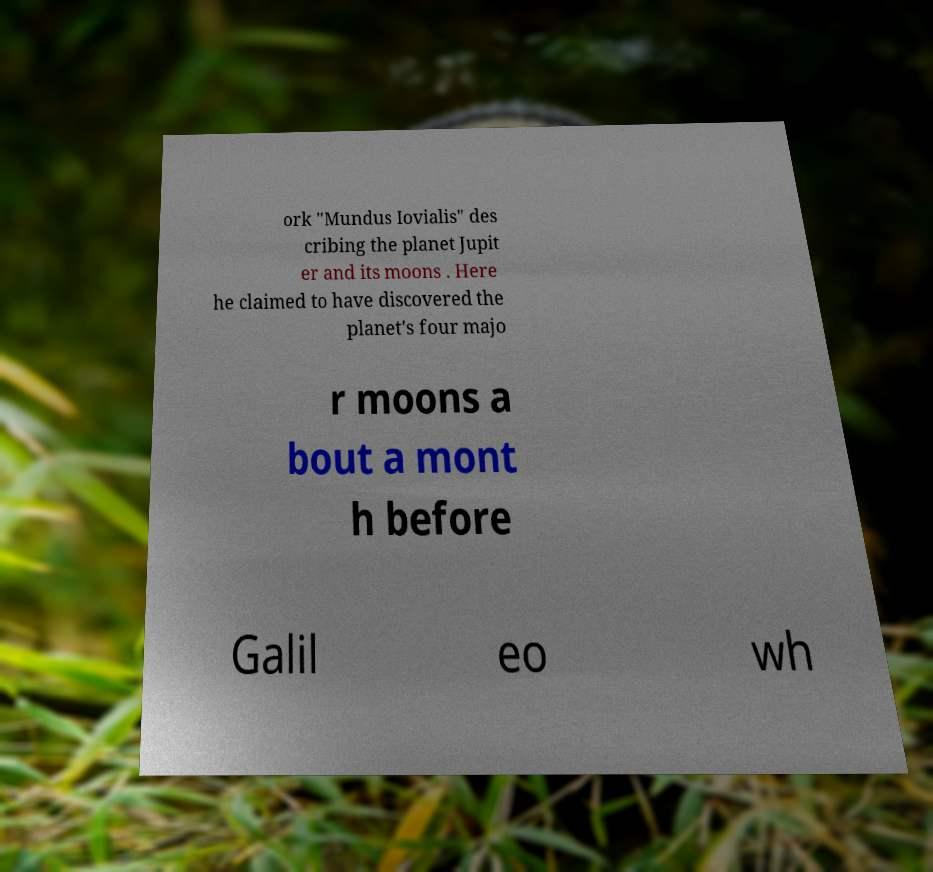Could you assist in decoding the text presented in this image and type it out clearly? ork "Mundus Iovialis" des cribing the planet Jupit er and its moons . Here he claimed to have discovered the planet's four majo r moons a bout a mont h before Galil eo wh 